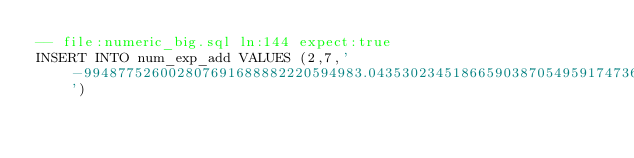Convert code to text. <code><loc_0><loc_0><loc_500><loc_500><_SQL_>-- file:numeric_big.sql ln:144 expect:true
INSERT INTO num_exp_add VALUES (2,7,'-994877526002807691688882220594983.04353023451866590387054959174736129501310680280823383331007646306243540953499740615246583399296334239109936336446284803020643582102868247857009494139535009572740621288230740389545481395')
</code> 